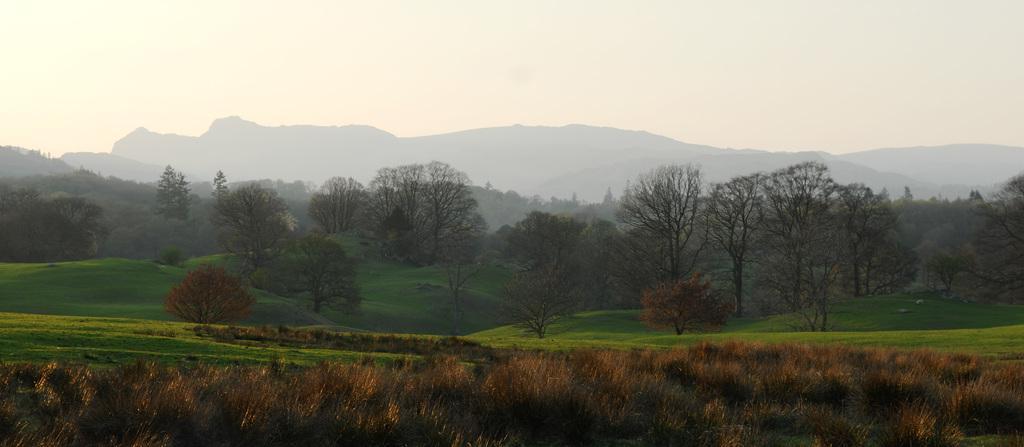Describe this image in one or two sentences. In the picture we can see grass, trees, and mountains. In the background there is sky. 